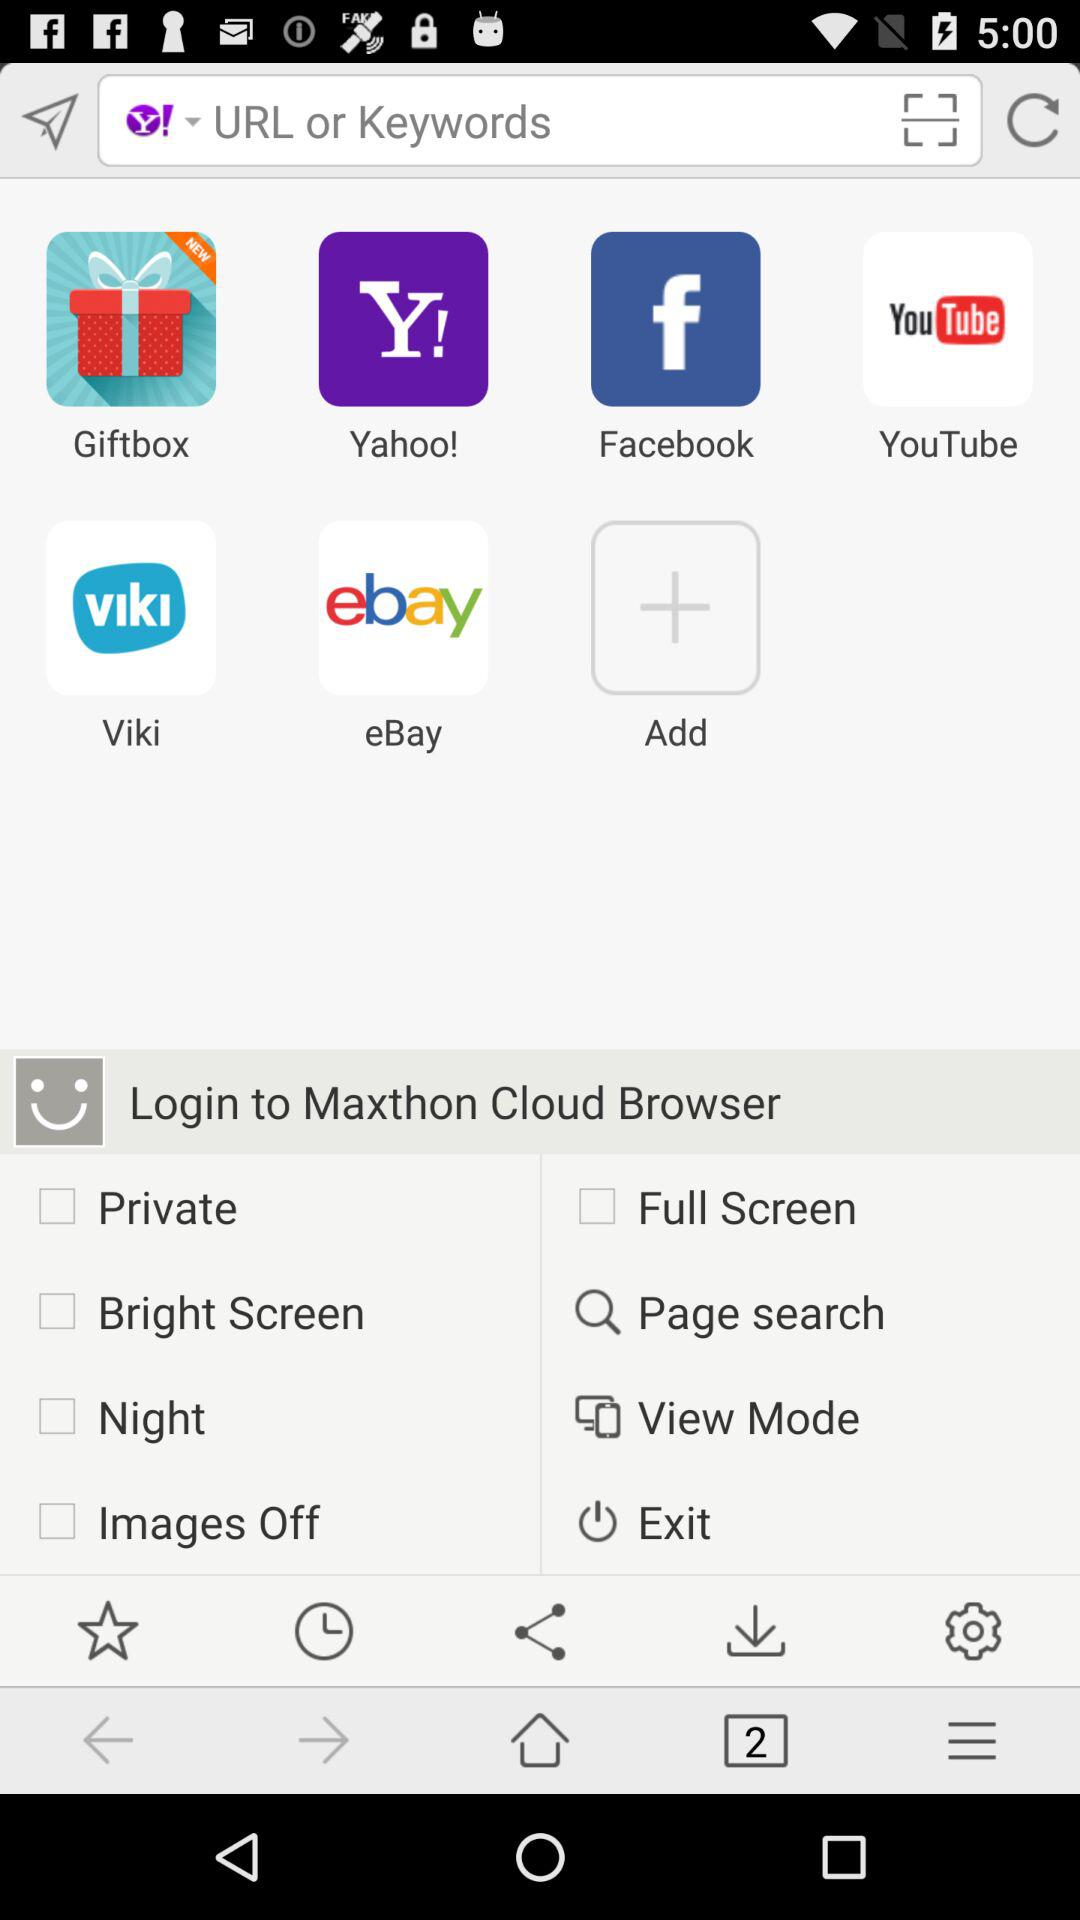Which options are unchecked? The unchecked options are "Private", "Bright Screen", "Night", "Images Off" and "Full Screen". 